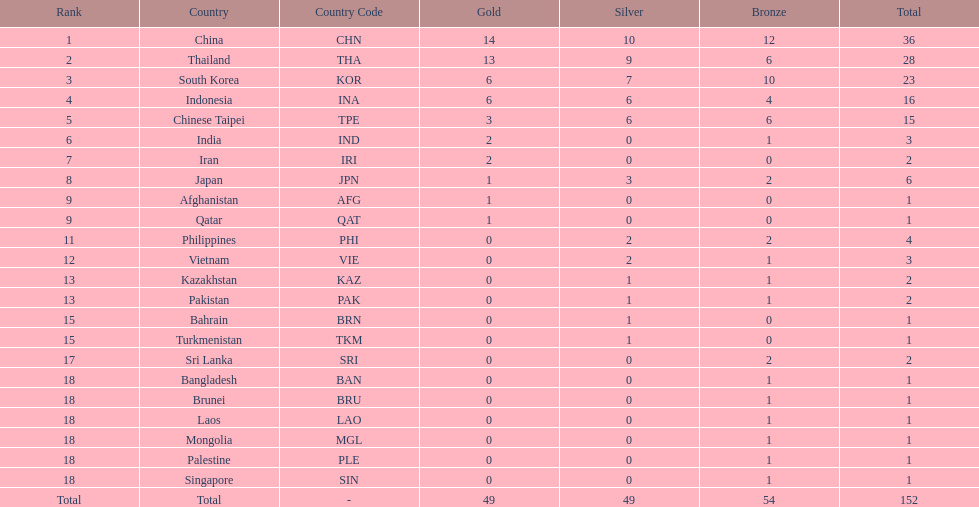How many more medals did india earn compared to pakistan? 1. 